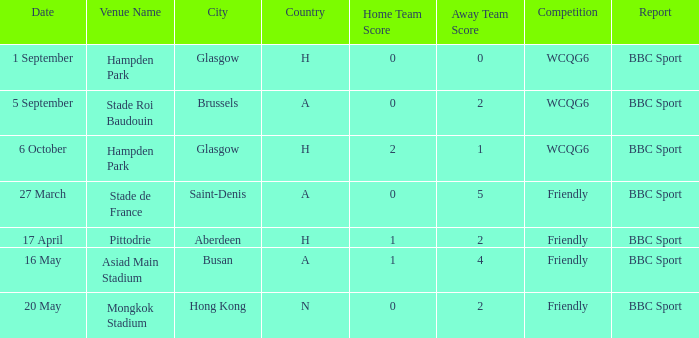Who documented the game on 6 october? BBC Sport. Could you parse the entire table as a dict? {'header': ['Date', 'Venue Name', 'City', 'Country', 'Home Team Score', 'Away Team Score', 'Competition', 'Report'], 'rows': [['1 September', 'Hampden Park', 'Glasgow', 'H', '0', '0', 'WCQG6', 'BBC Sport'], ['5 September', 'Stade Roi Baudouin', 'Brussels', 'A', '0', '2', 'WCQG6', 'BBC Sport'], ['6 October', 'Hampden Park', 'Glasgow', 'H', '2', '1', 'WCQG6', 'BBC Sport'], ['27 March', 'Stade de France', 'Saint-Denis', 'A', '0', '5', 'Friendly', 'BBC Sport'], ['17 April', 'Pittodrie', 'Aberdeen', 'H', '1', '2', 'Friendly', 'BBC Sport'], ['16 May', 'Asiad Main Stadium', 'Busan', 'A', '1', '4', 'Friendly', 'BBC Sport'], ['20 May', 'Mongkok Stadium', 'Hong Kong', 'N', '0', '2', 'Friendly', 'BBC Sport']]} 